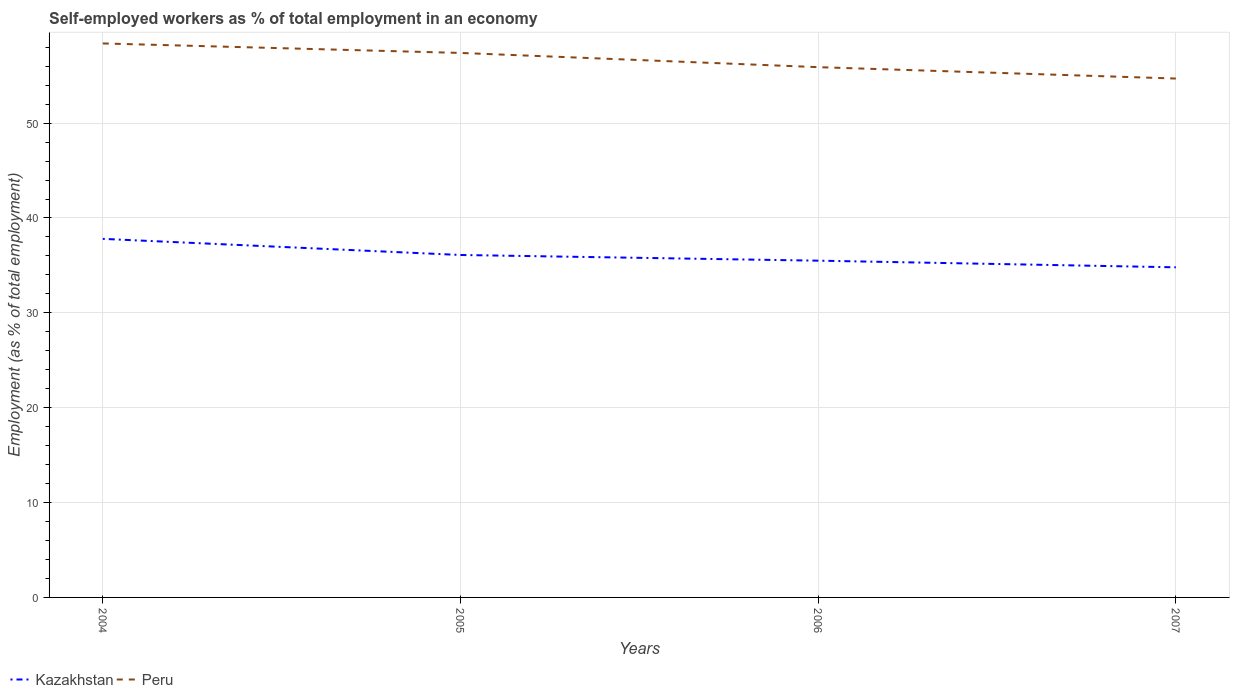How many different coloured lines are there?
Provide a succinct answer. 2. Across all years, what is the maximum percentage of self-employed workers in Kazakhstan?
Your answer should be very brief. 34.8. What is the total percentage of self-employed workers in Kazakhstan in the graph?
Your answer should be very brief. 3. What is the difference between the highest and the second highest percentage of self-employed workers in Kazakhstan?
Your response must be concise. 3. What is the difference between the highest and the lowest percentage of self-employed workers in Peru?
Offer a terse response. 2. How many lines are there?
Provide a short and direct response. 2. How many years are there in the graph?
Ensure brevity in your answer.  4. Does the graph contain any zero values?
Give a very brief answer. No. Does the graph contain grids?
Your response must be concise. Yes. How many legend labels are there?
Ensure brevity in your answer.  2. What is the title of the graph?
Provide a short and direct response. Self-employed workers as % of total employment in an economy. What is the label or title of the Y-axis?
Provide a short and direct response. Employment (as % of total employment). What is the Employment (as % of total employment) of Kazakhstan in 2004?
Provide a short and direct response. 37.8. What is the Employment (as % of total employment) in Peru in 2004?
Provide a short and direct response. 58.4. What is the Employment (as % of total employment) in Kazakhstan in 2005?
Offer a terse response. 36.1. What is the Employment (as % of total employment) of Peru in 2005?
Your answer should be compact. 57.4. What is the Employment (as % of total employment) in Kazakhstan in 2006?
Keep it short and to the point. 35.5. What is the Employment (as % of total employment) in Peru in 2006?
Offer a very short reply. 55.9. What is the Employment (as % of total employment) of Kazakhstan in 2007?
Your answer should be compact. 34.8. What is the Employment (as % of total employment) of Peru in 2007?
Ensure brevity in your answer.  54.7. Across all years, what is the maximum Employment (as % of total employment) in Kazakhstan?
Give a very brief answer. 37.8. Across all years, what is the maximum Employment (as % of total employment) in Peru?
Your answer should be compact. 58.4. Across all years, what is the minimum Employment (as % of total employment) in Kazakhstan?
Ensure brevity in your answer.  34.8. Across all years, what is the minimum Employment (as % of total employment) in Peru?
Provide a short and direct response. 54.7. What is the total Employment (as % of total employment) of Kazakhstan in the graph?
Offer a terse response. 144.2. What is the total Employment (as % of total employment) of Peru in the graph?
Your answer should be very brief. 226.4. What is the difference between the Employment (as % of total employment) in Peru in 2004 and that in 2005?
Offer a very short reply. 1. What is the difference between the Employment (as % of total employment) in Peru in 2004 and that in 2007?
Your answer should be very brief. 3.7. What is the difference between the Employment (as % of total employment) in Kazakhstan in 2005 and that in 2006?
Provide a short and direct response. 0.6. What is the difference between the Employment (as % of total employment) in Peru in 2005 and that in 2006?
Provide a succinct answer. 1.5. What is the difference between the Employment (as % of total employment) of Kazakhstan in 2005 and that in 2007?
Make the answer very short. 1.3. What is the difference between the Employment (as % of total employment) of Kazakhstan in 2006 and that in 2007?
Ensure brevity in your answer.  0.7. What is the difference between the Employment (as % of total employment) of Kazakhstan in 2004 and the Employment (as % of total employment) of Peru in 2005?
Provide a short and direct response. -19.6. What is the difference between the Employment (as % of total employment) in Kazakhstan in 2004 and the Employment (as % of total employment) in Peru in 2006?
Provide a short and direct response. -18.1. What is the difference between the Employment (as % of total employment) of Kazakhstan in 2004 and the Employment (as % of total employment) of Peru in 2007?
Offer a very short reply. -16.9. What is the difference between the Employment (as % of total employment) of Kazakhstan in 2005 and the Employment (as % of total employment) of Peru in 2006?
Provide a succinct answer. -19.8. What is the difference between the Employment (as % of total employment) of Kazakhstan in 2005 and the Employment (as % of total employment) of Peru in 2007?
Ensure brevity in your answer.  -18.6. What is the difference between the Employment (as % of total employment) of Kazakhstan in 2006 and the Employment (as % of total employment) of Peru in 2007?
Give a very brief answer. -19.2. What is the average Employment (as % of total employment) of Kazakhstan per year?
Give a very brief answer. 36.05. What is the average Employment (as % of total employment) of Peru per year?
Ensure brevity in your answer.  56.6. In the year 2004, what is the difference between the Employment (as % of total employment) of Kazakhstan and Employment (as % of total employment) of Peru?
Provide a short and direct response. -20.6. In the year 2005, what is the difference between the Employment (as % of total employment) in Kazakhstan and Employment (as % of total employment) in Peru?
Make the answer very short. -21.3. In the year 2006, what is the difference between the Employment (as % of total employment) of Kazakhstan and Employment (as % of total employment) of Peru?
Make the answer very short. -20.4. In the year 2007, what is the difference between the Employment (as % of total employment) of Kazakhstan and Employment (as % of total employment) of Peru?
Ensure brevity in your answer.  -19.9. What is the ratio of the Employment (as % of total employment) of Kazakhstan in 2004 to that in 2005?
Your response must be concise. 1.05. What is the ratio of the Employment (as % of total employment) of Peru in 2004 to that in 2005?
Provide a short and direct response. 1.02. What is the ratio of the Employment (as % of total employment) of Kazakhstan in 2004 to that in 2006?
Give a very brief answer. 1.06. What is the ratio of the Employment (as % of total employment) of Peru in 2004 to that in 2006?
Offer a very short reply. 1.04. What is the ratio of the Employment (as % of total employment) of Kazakhstan in 2004 to that in 2007?
Ensure brevity in your answer.  1.09. What is the ratio of the Employment (as % of total employment) in Peru in 2004 to that in 2007?
Your answer should be compact. 1.07. What is the ratio of the Employment (as % of total employment) of Kazakhstan in 2005 to that in 2006?
Provide a short and direct response. 1.02. What is the ratio of the Employment (as % of total employment) in Peru in 2005 to that in 2006?
Ensure brevity in your answer.  1.03. What is the ratio of the Employment (as % of total employment) in Kazakhstan in 2005 to that in 2007?
Your response must be concise. 1.04. What is the ratio of the Employment (as % of total employment) of Peru in 2005 to that in 2007?
Offer a very short reply. 1.05. What is the ratio of the Employment (as % of total employment) of Kazakhstan in 2006 to that in 2007?
Your answer should be very brief. 1.02. What is the ratio of the Employment (as % of total employment) of Peru in 2006 to that in 2007?
Give a very brief answer. 1.02. What is the difference between the highest and the second highest Employment (as % of total employment) of Kazakhstan?
Offer a terse response. 1.7. What is the difference between the highest and the second highest Employment (as % of total employment) of Peru?
Keep it short and to the point. 1. What is the difference between the highest and the lowest Employment (as % of total employment) of Kazakhstan?
Your response must be concise. 3. What is the difference between the highest and the lowest Employment (as % of total employment) of Peru?
Provide a succinct answer. 3.7. 